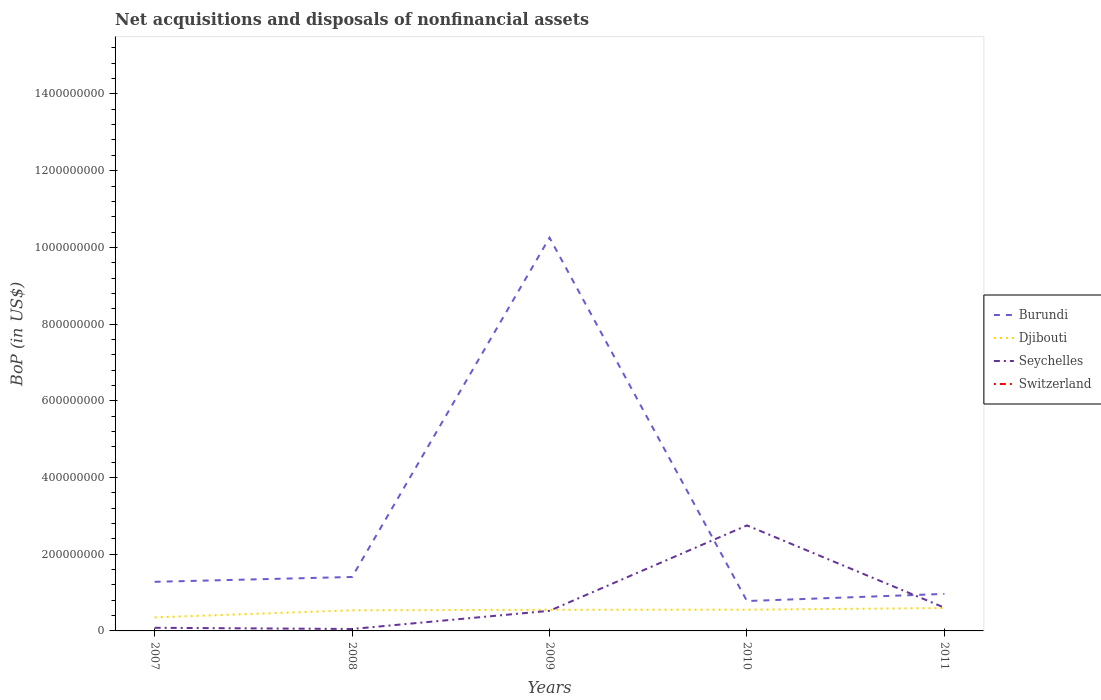Does the line corresponding to Djibouti intersect with the line corresponding to Seychelles?
Your answer should be very brief. Yes. Is the number of lines equal to the number of legend labels?
Give a very brief answer. No. Across all years, what is the maximum Balance of Payments in Switzerland?
Provide a succinct answer. 0. What is the total Balance of Payments in Burundi in the graph?
Give a very brief answer. 5.01e+07. What is the difference between the highest and the second highest Balance of Payments in Djibouti?
Your answer should be very brief. 2.44e+07. What is the difference between the highest and the lowest Balance of Payments in Djibouti?
Ensure brevity in your answer.  4. What is the difference between two consecutive major ticks on the Y-axis?
Your response must be concise. 2.00e+08. How many legend labels are there?
Offer a very short reply. 4. How are the legend labels stacked?
Offer a terse response. Vertical. What is the title of the graph?
Your answer should be very brief. Net acquisitions and disposals of nonfinancial assets. Does "Malta" appear as one of the legend labels in the graph?
Keep it short and to the point. No. What is the label or title of the Y-axis?
Provide a succinct answer. BoP (in US$). What is the BoP (in US$) in Burundi in 2007?
Your answer should be compact. 1.28e+08. What is the BoP (in US$) of Djibouti in 2007?
Provide a succinct answer. 3.53e+07. What is the BoP (in US$) in Seychelles in 2007?
Offer a terse response. 8.17e+06. What is the BoP (in US$) in Switzerland in 2007?
Provide a short and direct response. 0. What is the BoP (in US$) in Burundi in 2008?
Keep it short and to the point. 1.41e+08. What is the BoP (in US$) of Djibouti in 2008?
Your answer should be very brief. 5.37e+07. What is the BoP (in US$) in Seychelles in 2008?
Offer a terse response. 5.04e+06. What is the BoP (in US$) of Burundi in 2009?
Provide a succinct answer. 1.03e+09. What is the BoP (in US$) of Djibouti in 2009?
Offer a terse response. 5.51e+07. What is the BoP (in US$) in Seychelles in 2009?
Offer a terse response. 5.25e+07. What is the BoP (in US$) in Burundi in 2010?
Keep it short and to the point. 7.79e+07. What is the BoP (in US$) in Djibouti in 2010?
Make the answer very short. 5.53e+07. What is the BoP (in US$) in Seychelles in 2010?
Offer a very short reply. 2.75e+08. What is the BoP (in US$) of Switzerland in 2010?
Your response must be concise. 0. What is the BoP (in US$) of Burundi in 2011?
Offer a very short reply. 9.65e+07. What is the BoP (in US$) of Djibouti in 2011?
Your answer should be compact. 5.97e+07. What is the BoP (in US$) in Seychelles in 2011?
Keep it short and to the point. 6.06e+07. Across all years, what is the maximum BoP (in US$) of Burundi?
Your response must be concise. 1.03e+09. Across all years, what is the maximum BoP (in US$) of Djibouti?
Your answer should be very brief. 5.97e+07. Across all years, what is the maximum BoP (in US$) in Seychelles?
Keep it short and to the point. 2.75e+08. Across all years, what is the minimum BoP (in US$) of Burundi?
Make the answer very short. 7.79e+07. Across all years, what is the minimum BoP (in US$) in Djibouti?
Provide a short and direct response. 3.53e+07. Across all years, what is the minimum BoP (in US$) in Seychelles?
Offer a terse response. 5.04e+06. What is the total BoP (in US$) in Burundi in the graph?
Provide a short and direct response. 1.47e+09. What is the total BoP (in US$) in Djibouti in the graph?
Ensure brevity in your answer.  2.59e+08. What is the total BoP (in US$) of Seychelles in the graph?
Ensure brevity in your answer.  4.01e+08. What is the total BoP (in US$) in Switzerland in the graph?
Provide a short and direct response. 0. What is the difference between the BoP (in US$) in Burundi in 2007 and that in 2008?
Offer a very short reply. -1.27e+07. What is the difference between the BoP (in US$) in Djibouti in 2007 and that in 2008?
Make the answer very short. -1.85e+07. What is the difference between the BoP (in US$) of Seychelles in 2007 and that in 2008?
Keep it short and to the point. 3.13e+06. What is the difference between the BoP (in US$) in Burundi in 2007 and that in 2009?
Offer a terse response. -8.97e+08. What is the difference between the BoP (in US$) of Djibouti in 2007 and that in 2009?
Keep it short and to the point. -1.99e+07. What is the difference between the BoP (in US$) of Seychelles in 2007 and that in 2009?
Provide a short and direct response. -4.43e+07. What is the difference between the BoP (in US$) in Burundi in 2007 and that in 2010?
Ensure brevity in your answer.  5.01e+07. What is the difference between the BoP (in US$) in Djibouti in 2007 and that in 2010?
Your answer should be very brief. -2.00e+07. What is the difference between the BoP (in US$) of Seychelles in 2007 and that in 2010?
Offer a terse response. -2.67e+08. What is the difference between the BoP (in US$) of Burundi in 2007 and that in 2011?
Offer a terse response. 3.15e+07. What is the difference between the BoP (in US$) in Djibouti in 2007 and that in 2011?
Provide a succinct answer. -2.44e+07. What is the difference between the BoP (in US$) of Seychelles in 2007 and that in 2011?
Provide a succinct answer. -5.25e+07. What is the difference between the BoP (in US$) of Burundi in 2008 and that in 2009?
Offer a terse response. -8.85e+08. What is the difference between the BoP (in US$) of Djibouti in 2008 and that in 2009?
Your response must be concise. -1.39e+06. What is the difference between the BoP (in US$) in Seychelles in 2008 and that in 2009?
Give a very brief answer. -4.74e+07. What is the difference between the BoP (in US$) of Burundi in 2008 and that in 2010?
Make the answer very short. 6.28e+07. What is the difference between the BoP (in US$) in Djibouti in 2008 and that in 2010?
Your answer should be compact. -1.58e+06. What is the difference between the BoP (in US$) of Seychelles in 2008 and that in 2010?
Offer a very short reply. -2.70e+08. What is the difference between the BoP (in US$) in Burundi in 2008 and that in 2011?
Make the answer very short. 4.42e+07. What is the difference between the BoP (in US$) in Djibouti in 2008 and that in 2011?
Make the answer very short. -5.94e+06. What is the difference between the BoP (in US$) in Seychelles in 2008 and that in 2011?
Your response must be concise. -5.56e+07. What is the difference between the BoP (in US$) in Burundi in 2009 and that in 2010?
Keep it short and to the point. 9.47e+08. What is the difference between the BoP (in US$) of Djibouti in 2009 and that in 2010?
Give a very brief answer. -1.86e+05. What is the difference between the BoP (in US$) in Seychelles in 2009 and that in 2010?
Provide a short and direct response. -2.23e+08. What is the difference between the BoP (in US$) of Burundi in 2009 and that in 2011?
Your answer should be very brief. 9.29e+08. What is the difference between the BoP (in US$) of Djibouti in 2009 and that in 2011?
Ensure brevity in your answer.  -4.55e+06. What is the difference between the BoP (in US$) of Seychelles in 2009 and that in 2011?
Your answer should be very brief. -8.19e+06. What is the difference between the BoP (in US$) of Burundi in 2010 and that in 2011?
Make the answer very short. -1.86e+07. What is the difference between the BoP (in US$) in Djibouti in 2010 and that in 2011?
Offer a very short reply. -4.36e+06. What is the difference between the BoP (in US$) in Seychelles in 2010 and that in 2011?
Your response must be concise. 2.14e+08. What is the difference between the BoP (in US$) in Burundi in 2007 and the BoP (in US$) in Djibouti in 2008?
Give a very brief answer. 7.43e+07. What is the difference between the BoP (in US$) of Burundi in 2007 and the BoP (in US$) of Seychelles in 2008?
Offer a terse response. 1.23e+08. What is the difference between the BoP (in US$) of Djibouti in 2007 and the BoP (in US$) of Seychelles in 2008?
Keep it short and to the point. 3.02e+07. What is the difference between the BoP (in US$) of Burundi in 2007 and the BoP (in US$) of Djibouti in 2009?
Provide a succinct answer. 7.29e+07. What is the difference between the BoP (in US$) in Burundi in 2007 and the BoP (in US$) in Seychelles in 2009?
Your answer should be compact. 7.56e+07. What is the difference between the BoP (in US$) of Djibouti in 2007 and the BoP (in US$) of Seychelles in 2009?
Offer a very short reply. -1.72e+07. What is the difference between the BoP (in US$) of Burundi in 2007 and the BoP (in US$) of Djibouti in 2010?
Offer a very short reply. 7.27e+07. What is the difference between the BoP (in US$) of Burundi in 2007 and the BoP (in US$) of Seychelles in 2010?
Offer a terse response. -1.47e+08. What is the difference between the BoP (in US$) in Djibouti in 2007 and the BoP (in US$) in Seychelles in 2010?
Offer a very short reply. -2.40e+08. What is the difference between the BoP (in US$) of Burundi in 2007 and the BoP (in US$) of Djibouti in 2011?
Offer a terse response. 6.83e+07. What is the difference between the BoP (in US$) of Burundi in 2007 and the BoP (in US$) of Seychelles in 2011?
Your response must be concise. 6.74e+07. What is the difference between the BoP (in US$) in Djibouti in 2007 and the BoP (in US$) in Seychelles in 2011?
Offer a terse response. -2.54e+07. What is the difference between the BoP (in US$) in Burundi in 2008 and the BoP (in US$) in Djibouti in 2009?
Your answer should be compact. 8.55e+07. What is the difference between the BoP (in US$) in Burundi in 2008 and the BoP (in US$) in Seychelles in 2009?
Make the answer very short. 8.82e+07. What is the difference between the BoP (in US$) in Djibouti in 2008 and the BoP (in US$) in Seychelles in 2009?
Offer a very short reply. 1.28e+06. What is the difference between the BoP (in US$) of Burundi in 2008 and the BoP (in US$) of Djibouti in 2010?
Offer a terse response. 8.54e+07. What is the difference between the BoP (in US$) of Burundi in 2008 and the BoP (in US$) of Seychelles in 2010?
Ensure brevity in your answer.  -1.34e+08. What is the difference between the BoP (in US$) of Djibouti in 2008 and the BoP (in US$) of Seychelles in 2010?
Provide a succinct answer. -2.21e+08. What is the difference between the BoP (in US$) of Burundi in 2008 and the BoP (in US$) of Djibouti in 2011?
Your response must be concise. 8.10e+07. What is the difference between the BoP (in US$) of Burundi in 2008 and the BoP (in US$) of Seychelles in 2011?
Your answer should be compact. 8.00e+07. What is the difference between the BoP (in US$) of Djibouti in 2008 and the BoP (in US$) of Seychelles in 2011?
Provide a short and direct response. -6.91e+06. What is the difference between the BoP (in US$) in Burundi in 2009 and the BoP (in US$) in Djibouti in 2010?
Ensure brevity in your answer.  9.70e+08. What is the difference between the BoP (in US$) of Burundi in 2009 and the BoP (in US$) of Seychelles in 2010?
Your response must be concise. 7.50e+08. What is the difference between the BoP (in US$) of Djibouti in 2009 and the BoP (in US$) of Seychelles in 2010?
Offer a terse response. -2.20e+08. What is the difference between the BoP (in US$) in Burundi in 2009 and the BoP (in US$) in Djibouti in 2011?
Your answer should be very brief. 9.66e+08. What is the difference between the BoP (in US$) in Burundi in 2009 and the BoP (in US$) in Seychelles in 2011?
Offer a terse response. 9.65e+08. What is the difference between the BoP (in US$) of Djibouti in 2009 and the BoP (in US$) of Seychelles in 2011?
Offer a terse response. -5.52e+06. What is the difference between the BoP (in US$) of Burundi in 2010 and the BoP (in US$) of Djibouti in 2011?
Provide a succinct answer. 1.82e+07. What is the difference between the BoP (in US$) of Burundi in 2010 and the BoP (in US$) of Seychelles in 2011?
Your response must be concise. 1.73e+07. What is the difference between the BoP (in US$) of Djibouti in 2010 and the BoP (in US$) of Seychelles in 2011?
Give a very brief answer. -5.33e+06. What is the average BoP (in US$) in Burundi per year?
Offer a terse response. 2.94e+08. What is the average BoP (in US$) of Djibouti per year?
Your answer should be compact. 5.18e+07. What is the average BoP (in US$) of Seychelles per year?
Keep it short and to the point. 8.03e+07. What is the average BoP (in US$) in Switzerland per year?
Make the answer very short. 0. In the year 2007, what is the difference between the BoP (in US$) of Burundi and BoP (in US$) of Djibouti?
Give a very brief answer. 9.27e+07. In the year 2007, what is the difference between the BoP (in US$) in Burundi and BoP (in US$) in Seychelles?
Ensure brevity in your answer.  1.20e+08. In the year 2007, what is the difference between the BoP (in US$) of Djibouti and BoP (in US$) of Seychelles?
Your response must be concise. 2.71e+07. In the year 2008, what is the difference between the BoP (in US$) in Burundi and BoP (in US$) in Djibouti?
Offer a terse response. 8.69e+07. In the year 2008, what is the difference between the BoP (in US$) of Burundi and BoP (in US$) of Seychelles?
Your response must be concise. 1.36e+08. In the year 2008, what is the difference between the BoP (in US$) in Djibouti and BoP (in US$) in Seychelles?
Provide a succinct answer. 4.87e+07. In the year 2009, what is the difference between the BoP (in US$) of Burundi and BoP (in US$) of Djibouti?
Offer a terse response. 9.70e+08. In the year 2009, what is the difference between the BoP (in US$) of Burundi and BoP (in US$) of Seychelles?
Your answer should be compact. 9.73e+08. In the year 2009, what is the difference between the BoP (in US$) of Djibouti and BoP (in US$) of Seychelles?
Offer a very short reply. 2.67e+06. In the year 2010, what is the difference between the BoP (in US$) in Burundi and BoP (in US$) in Djibouti?
Give a very brief answer. 2.26e+07. In the year 2010, what is the difference between the BoP (in US$) of Burundi and BoP (in US$) of Seychelles?
Offer a very short reply. -1.97e+08. In the year 2010, what is the difference between the BoP (in US$) of Djibouti and BoP (in US$) of Seychelles?
Keep it short and to the point. -2.20e+08. In the year 2011, what is the difference between the BoP (in US$) in Burundi and BoP (in US$) in Djibouti?
Your answer should be very brief. 3.68e+07. In the year 2011, what is the difference between the BoP (in US$) of Burundi and BoP (in US$) of Seychelles?
Make the answer very short. 3.58e+07. In the year 2011, what is the difference between the BoP (in US$) in Djibouti and BoP (in US$) in Seychelles?
Your response must be concise. -9.69e+05. What is the ratio of the BoP (in US$) of Burundi in 2007 to that in 2008?
Ensure brevity in your answer.  0.91. What is the ratio of the BoP (in US$) of Djibouti in 2007 to that in 2008?
Offer a very short reply. 0.66. What is the ratio of the BoP (in US$) of Seychelles in 2007 to that in 2008?
Your response must be concise. 1.62. What is the ratio of the BoP (in US$) of Burundi in 2007 to that in 2009?
Ensure brevity in your answer.  0.12. What is the ratio of the BoP (in US$) of Djibouti in 2007 to that in 2009?
Provide a succinct answer. 0.64. What is the ratio of the BoP (in US$) in Seychelles in 2007 to that in 2009?
Your answer should be compact. 0.16. What is the ratio of the BoP (in US$) in Burundi in 2007 to that in 2010?
Your answer should be compact. 1.64. What is the ratio of the BoP (in US$) of Djibouti in 2007 to that in 2010?
Your answer should be very brief. 0.64. What is the ratio of the BoP (in US$) in Seychelles in 2007 to that in 2010?
Ensure brevity in your answer.  0.03. What is the ratio of the BoP (in US$) of Burundi in 2007 to that in 2011?
Offer a terse response. 1.33. What is the ratio of the BoP (in US$) in Djibouti in 2007 to that in 2011?
Provide a short and direct response. 0.59. What is the ratio of the BoP (in US$) of Seychelles in 2007 to that in 2011?
Your answer should be very brief. 0.13. What is the ratio of the BoP (in US$) in Burundi in 2008 to that in 2009?
Provide a short and direct response. 0.14. What is the ratio of the BoP (in US$) in Djibouti in 2008 to that in 2009?
Make the answer very short. 0.97. What is the ratio of the BoP (in US$) in Seychelles in 2008 to that in 2009?
Provide a succinct answer. 0.1. What is the ratio of the BoP (in US$) of Burundi in 2008 to that in 2010?
Offer a very short reply. 1.81. What is the ratio of the BoP (in US$) in Djibouti in 2008 to that in 2010?
Your response must be concise. 0.97. What is the ratio of the BoP (in US$) in Seychelles in 2008 to that in 2010?
Provide a succinct answer. 0.02. What is the ratio of the BoP (in US$) of Burundi in 2008 to that in 2011?
Provide a succinct answer. 1.46. What is the ratio of the BoP (in US$) of Djibouti in 2008 to that in 2011?
Your answer should be compact. 0.9. What is the ratio of the BoP (in US$) of Seychelles in 2008 to that in 2011?
Provide a short and direct response. 0.08. What is the ratio of the BoP (in US$) in Burundi in 2009 to that in 2010?
Provide a succinct answer. 13.16. What is the ratio of the BoP (in US$) in Seychelles in 2009 to that in 2010?
Offer a very short reply. 0.19. What is the ratio of the BoP (in US$) in Burundi in 2009 to that in 2011?
Offer a terse response. 10.63. What is the ratio of the BoP (in US$) in Djibouti in 2009 to that in 2011?
Keep it short and to the point. 0.92. What is the ratio of the BoP (in US$) of Seychelles in 2009 to that in 2011?
Give a very brief answer. 0.86. What is the ratio of the BoP (in US$) in Burundi in 2010 to that in 2011?
Your answer should be very brief. 0.81. What is the ratio of the BoP (in US$) in Djibouti in 2010 to that in 2011?
Your answer should be compact. 0.93. What is the ratio of the BoP (in US$) in Seychelles in 2010 to that in 2011?
Give a very brief answer. 4.54. What is the difference between the highest and the second highest BoP (in US$) in Burundi?
Your response must be concise. 8.85e+08. What is the difference between the highest and the second highest BoP (in US$) in Djibouti?
Your answer should be very brief. 4.36e+06. What is the difference between the highest and the second highest BoP (in US$) in Seychelles?
Your answer should be very brief. 2.14e+08. What is the difference between the highest and the lowest BoP (in US$) in Burundi?
Offer a very short reply. 9.47e+08. What is the difference between the highest and the lowest BoP (in US$) of Djibouti?
Offer a terse response. 2.44e+07. What is the difference between the highest and the lowest BoP (in US$) of Seychelles?
Ensure brevity in your answer.  2.70e+08. 